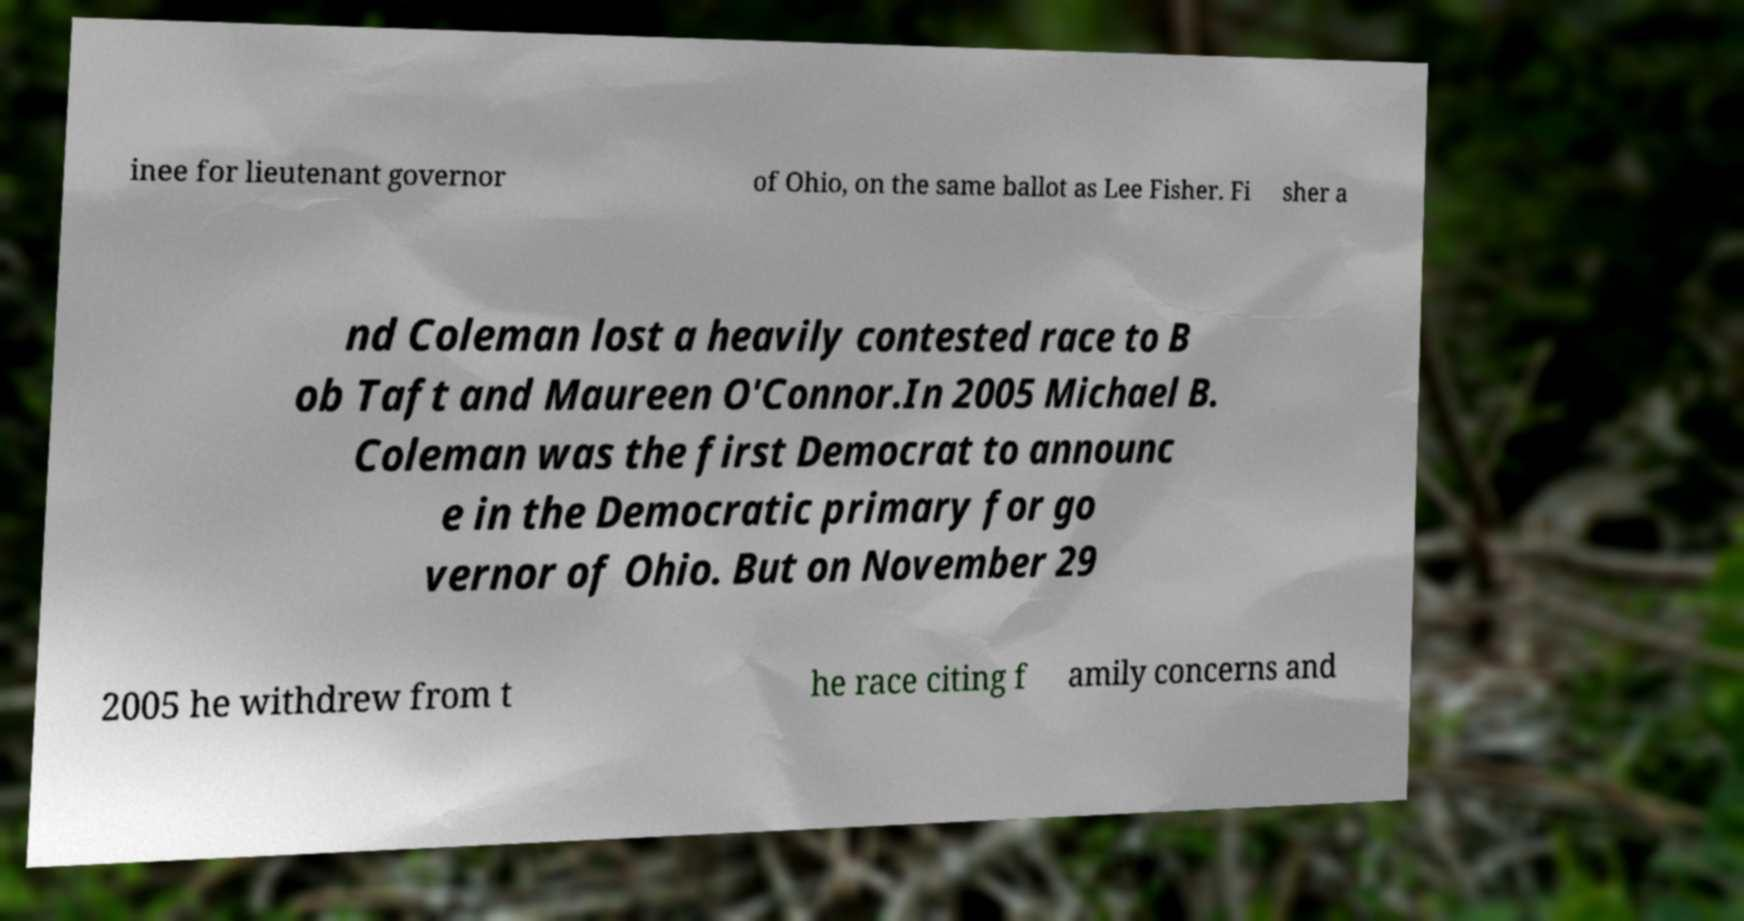Please identify and transcribe the text found in this image. inee for lieutenant governor of Ohio, on the same ballot as Lee Fisher. Fi sher a nd Coleman lost a heavily contested race to B ob Taft and Maureen O'Connor.In 2005 Michael B. Coleman was the first Democrat to announc e in the Democratic primary for go vernor of Ohio. But on November 29 2005 he withdrew from t he race citing f amily concerns and 